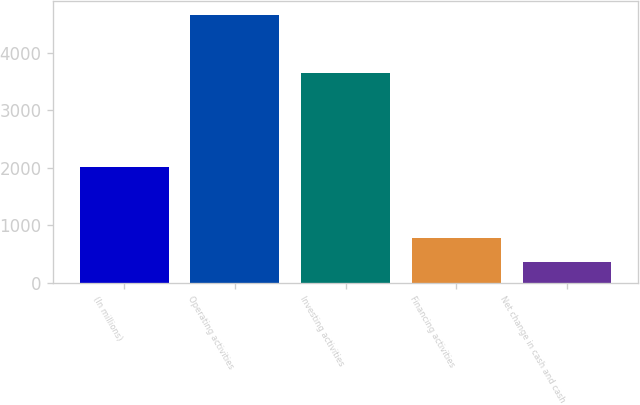<chart> <loc_0><loc_0><loc_500><loc_500><bar_chart><fcel>(In millions)<fcel>Operating activities<fcel>Investing activities<fcel>Financing activities<fcel>Net change in cash and cash<nl><fcel>2007<fcel>4656<fcel>3654<fcel>789.6<fcel>360<nl></chart> 